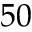Convert formula to latex. <formula><loc_0><loc_0><loc_500><loc_500>5 0</formula> 